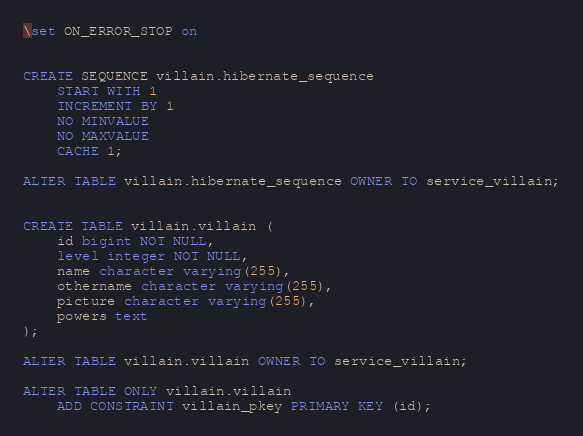<code> <loc_0><loc_0><loc_500><loc_500><_SQL_>\set ON_ERROR_STOP on


CREATE SEQUENCE villain.hibernate_sequence
    START WITH 1
    INCREMENT BY 1
    NO MINVALUE
    NO MAXVALUE
    CACHE 1;

ALTER TABLE villain.hibernate_sequence OWNER TO service_villain;


CREATE TABLE villain.villain (
    id bigint NOT NULL,
    level integer NOT NULL,
    name character varying(255),
    othername character varying(255),
    picture character varying(255),
    powers text
);

ALTER TABLE villain.villain OWNER TO service_villain;

ALTER TABLE ONLY villain.villain
    ADD CONSTRAINT villain_pkey PRIMARY KEY (id);
</code> 